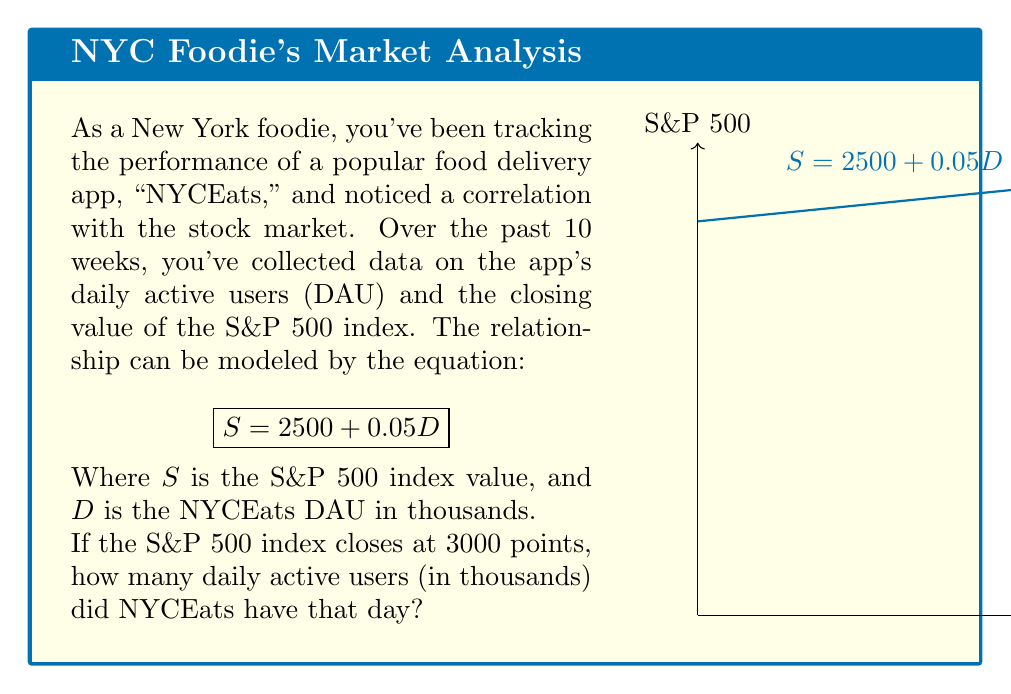What is the answer to this math problem? Let's approach this step-by-step:

1) We're given the equation: $S = 2500 + 0.05D$

2) We know that $S = 3000$ (the S&P 500 index value), and we need to find $D$ (the NYCEats DAU in thousands).

3) Let's substitute the known value into the equation:

   $3000 = 2500 + 0.05D$

4) Now, we need to solve for $D$. First, let's subtract 2500 from both sides:

   $3000 - 2500 = 0.05D$
   $500 = 0.05D$

5) To isolate $D$, we divide both sides by 0.05:

   $\frac{500}{0.05} = D$

6) Let's calculate this:

   $D = 10,000$

7) Remember, $D$ is in thousands of users. So this result means 10,000 thousand users, or 10 million users.
Answer: 10,000 (representing 10 million users) 